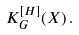<formula> <loc_0><loc_0><loc_500><loc_500>K ^ { [ H ] } _ { G } ( X ) \, .</formula> 